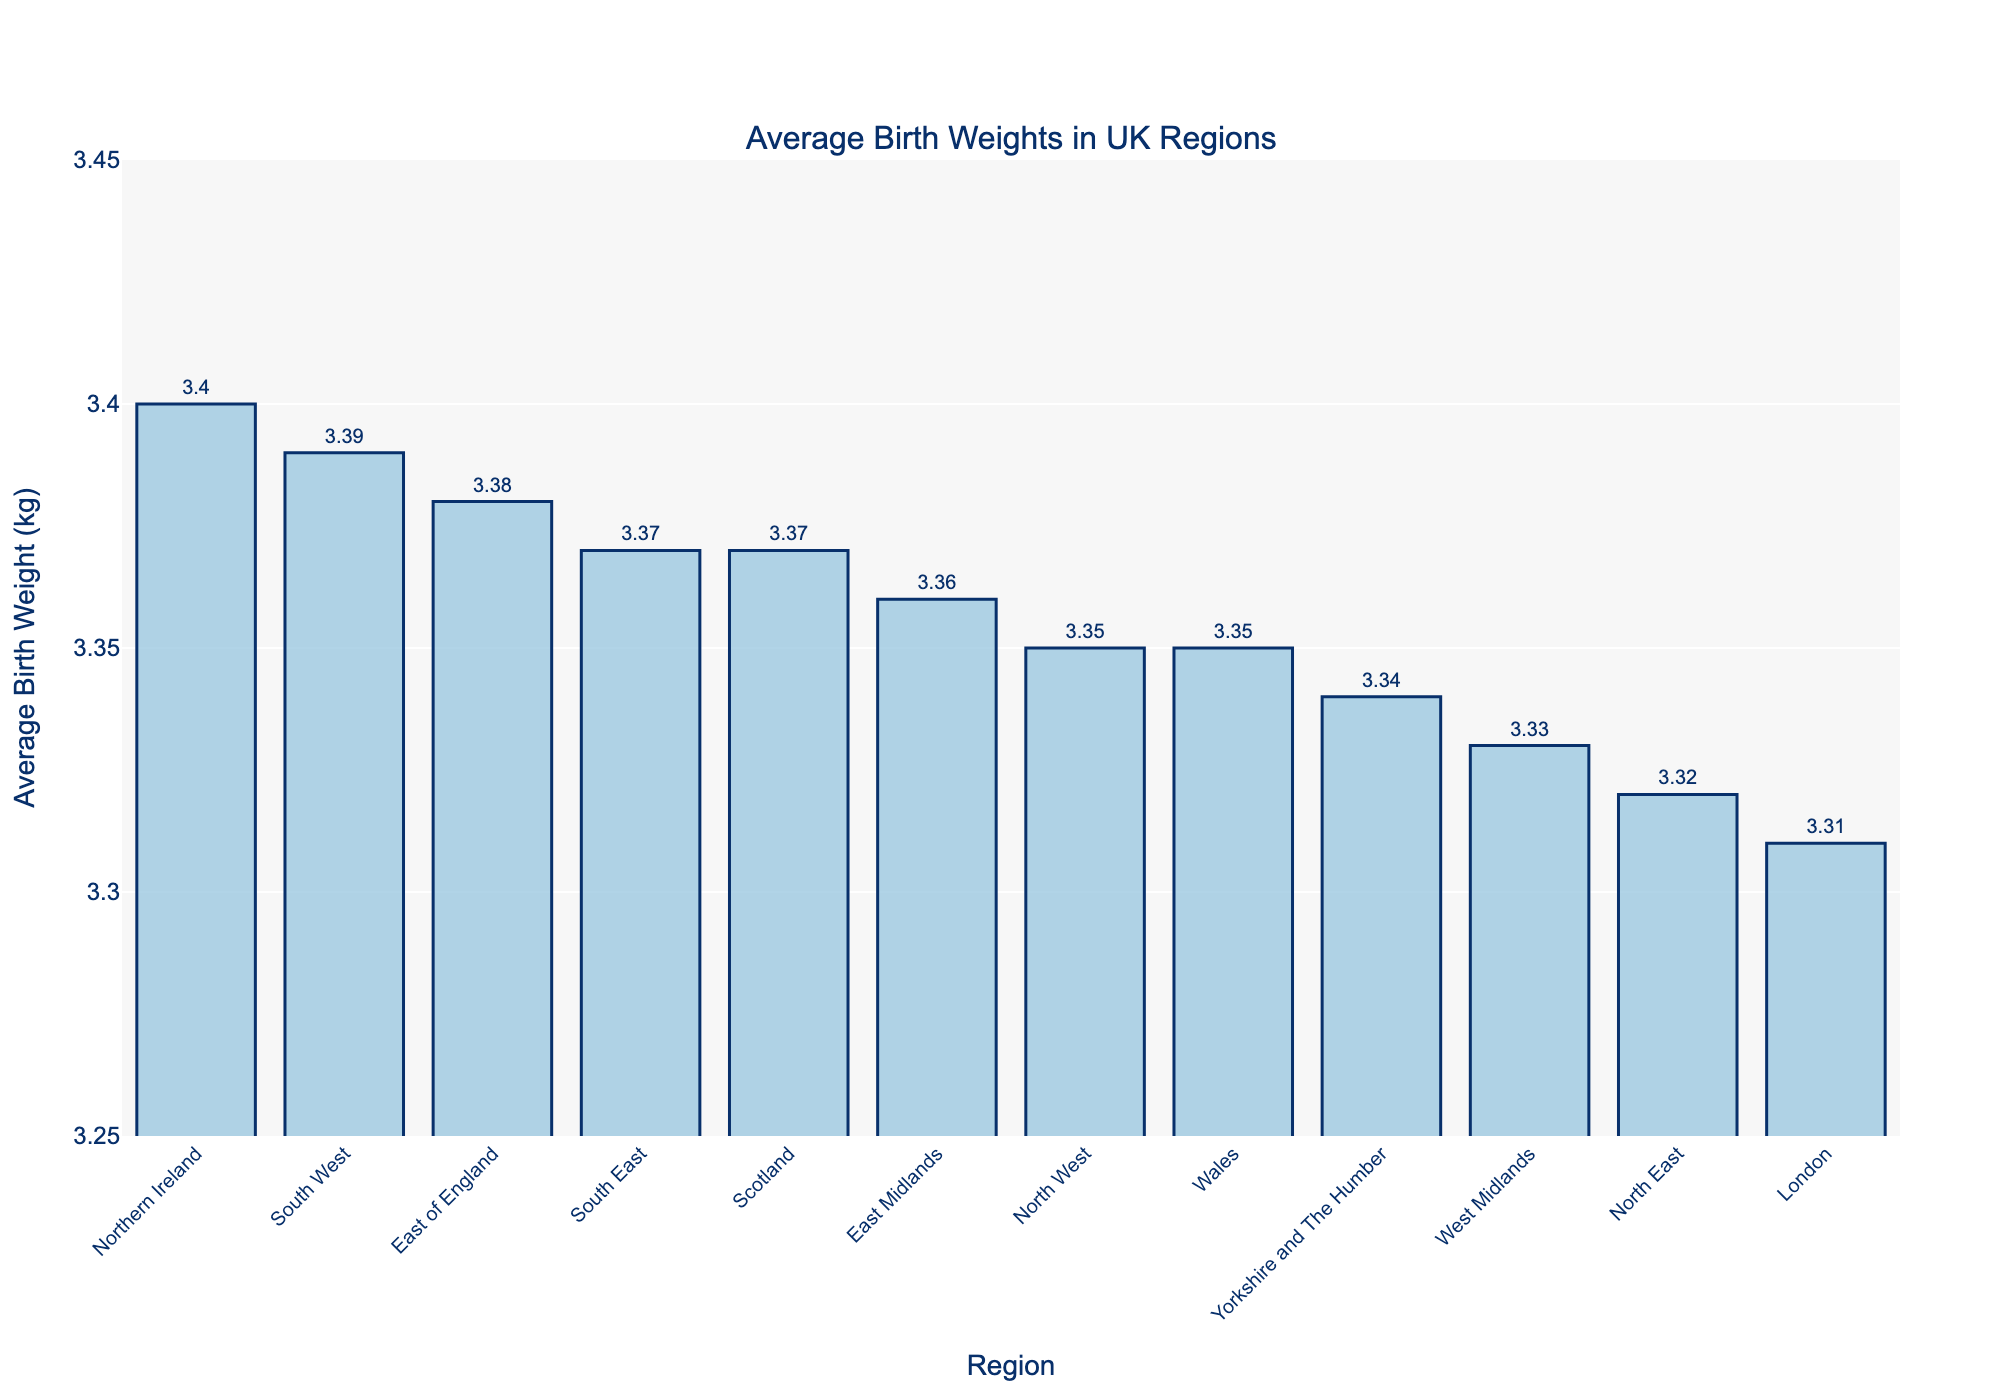Which region has the highest average birth weight? The region with the highest bar corresponds to Northern Ireland, and its value is 3.40 kg, indicating it has the highest average birth weight.
Answer: Northern Ireland Which region has the lowest average birth weight? The region with the shortest bar is London, with a value of 3.31 kg, indicating the lowest average birth weight.
Answer: London What is the difference in average birth weight between the South West and London? The average birth weight in the South West is 3.39 kg, and in London, it is 3.31 kg. The difference is 3.39 - 3.31 = 0.08 kg.
Answer: 0.08 kg Which regions have an average birth weight greater than 3.35 kg? Regions with bars higher than the 3.35 kg mark are East Midlands (3.36 kg), East of England (3.38 kg), South East (3.37 kg), South West (3.39 kg), Scotland (3.37 kg), and Northern Ireland (3.40 kg).
Answer: East Midlands, East of England, South East, South West, Scotland, Northern Ireland What is the sum of the average birth weights for Wales and Scotland? The average birth weight for Wales is 3.35 kg and for Scotland is 3.37 kg. The sum is 3.35 + 3.37 = 6.72 kg.
Answer: 6.72 kg How many regions have an average birth weight less than 3.33 kg? Regions with bars below 3.33 kg are North East (3.32 kg), West Midlands (3.33 kg), and London (3.31 kg). There are 3 regions.
Answer: 3 regions What is the median average birth weight across all regions? Sorting the average birth weights, the middle value(s) is(are): 3.32, 3.33, 3.34, 3.35, 3.35, 3.36, 3.37, 3.37, 3.38, 3.39, 3.40. The median is the average of the 6th and 7th values: (3.36 + 3.37)/2 = 3.365 kg.
Answer: 3.365 kg How does the average birth weight in East of England compare with the national average of 3.35 kg? The average birth weight in East of England is 3.38 kg, which is 0.03 kg higher than the national average of 3.35 kg.
Answer: 0.03 kg higher Are there any regions where the average birth weight equals 3.35 kg? The regions with an average birth weight of 3.35 kg are North West and Wales.
Answer: North West, Wales 